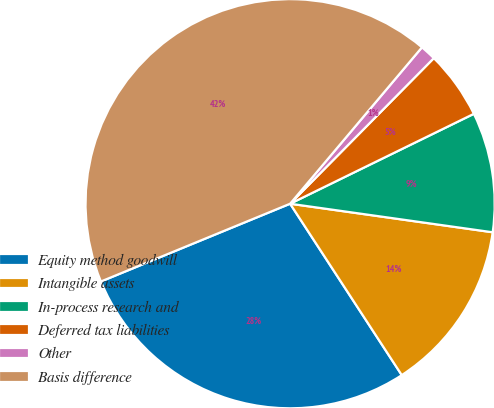Convert chart to OTSL. <chart><loc_0><loc_0><loc_500><loc_500><pie_chart><fcel>Equity method goodwill<fcel>Intangible assets<fcel>In-process research and<fcel>Deferred tax liabilities<fcel>Other<fcel>Basis difference<nl><fcel>27.98%<fcel>13.58%<fcel>9.47%<fcel>5.36%<fcel>1.25%<fcel>42.35%<nl></chart> 